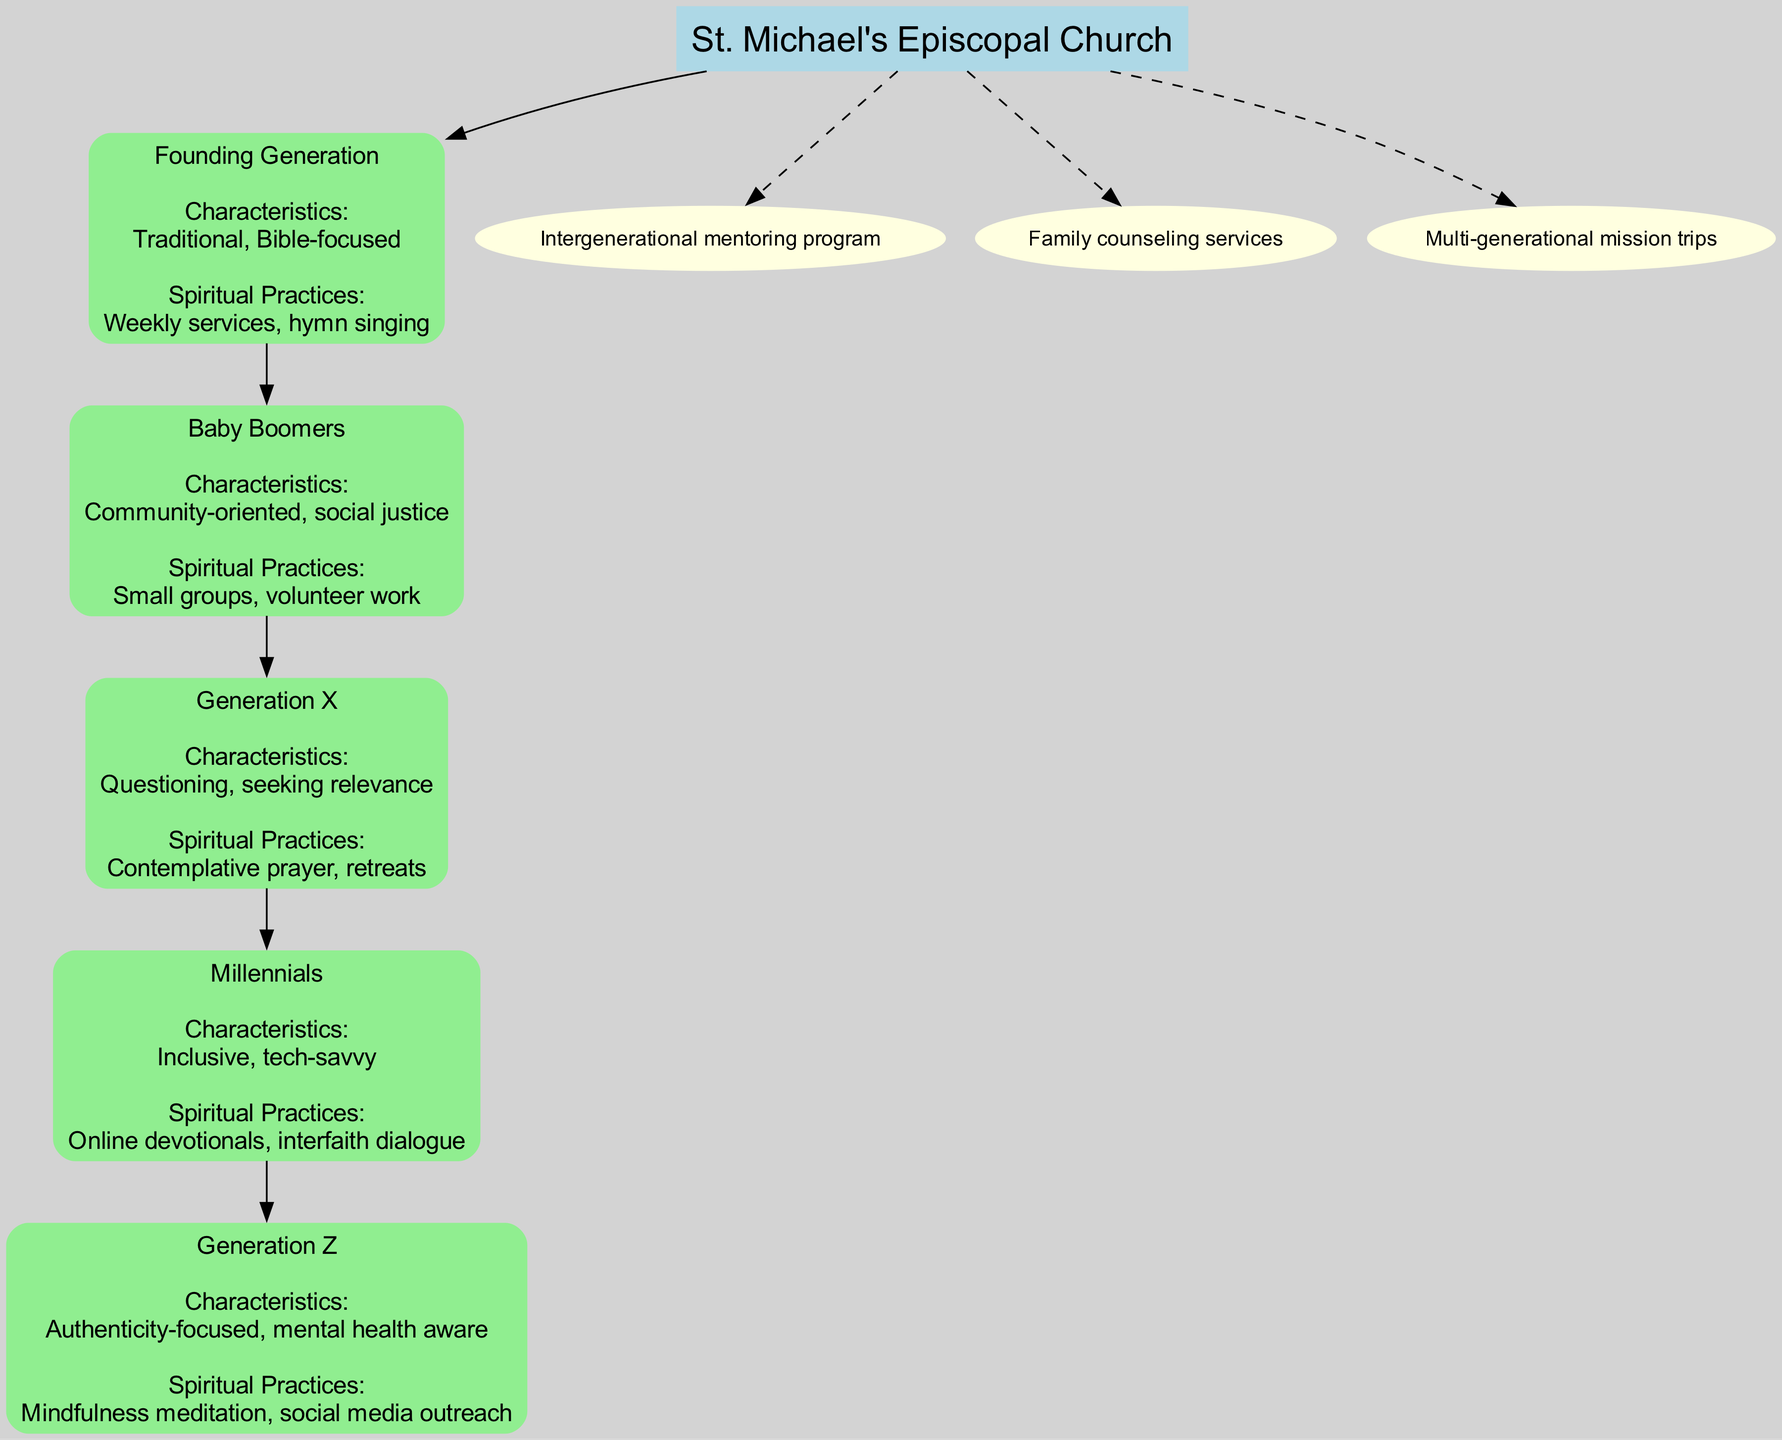What is the name of the root node? The root node represents the central entity of the diagram, which is explicitly stated at the top. It is labeled as "St. Michael's Episcopal Church." Therefore, the name of the root node is derived directly from this label.
Answer: St. Michael's Episcopal Church How many generations are represented in the diagram? By counting the "generations" listed within the structure of the diagram, we identify five distinct generations included: the Founding Generation, Baby Boomers, Generation X, Millennials, and Generation Z. Counting these entries gives us the total number.
Answer: 5 What is the personal focus of Generation Z? Looking specifically at Generation Z, the characteristic described in the diagram highlights their focus on authenticity and mental health awareness. This information is captured under the characteristics section for this generation.
Answer: Authenticity-focused, mental health aware Which generation is community-oriented? The characteristic of being community-oriented is associated with the Baby Boomers as labeled in the diagram. This information is directly mentioned in their descriptive characteristics.
Answer: Baby Boomers What is an example of a spiritual practice for Millennials? The spiritual practices associated with Millennials highlight their engagement in online devotionals and interfaith dialogue. By selecting any of these examples provided in their section, we can respond accordingly.
Answer: Online devotionals Which generation is known for its questioning nature? Generation X is identified in the diagram as having characteristics that describe them as questioning and seeking relevance. This specific identification occurs in their generational description.
Answer: Generation X How many cross-generational initiatives are listed? The diagram shows three distinct cross-generational initiatives that connect the congregation, representing collaborative efforts across generations. A count of these initiatives provides the answer.
Answer: 3 What are the spiritual practices emphasized in the Founding Generation? The Founding Generation's spiritual practices encompass weekly services and hymn singing, which are directly stated in the diagram under their section. This provides a clear sense of their religious engagement.
Answer: Weekly services, hymn singing What shape is used for the nodes representing generations? The nodes for the generations are designed with a rounded box shape style in the diagram, as described in the node attributes for those entries. This shapes their representation visually in a specific manner.
Answer: Box 